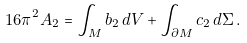Convert formula to latex. <formula><loc_0><loc_0><loc_500><loc_500>1 6 \pi ^ { 2 } A _ { 2 } = \int _ { M } b _ { 2 } \, d V + \int _ { \partial M } c _ { 2 } \, d \Sigma \, .</formula> 